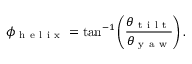<formula> <loc_0><loc_0><loc_500><loc_500>\phi _ { h e l i x } = \tan ^ { - 1 } \left ( \frac { \theta _ { t i l t } } { \theta _ { y a w } } \right ) .</formula> 